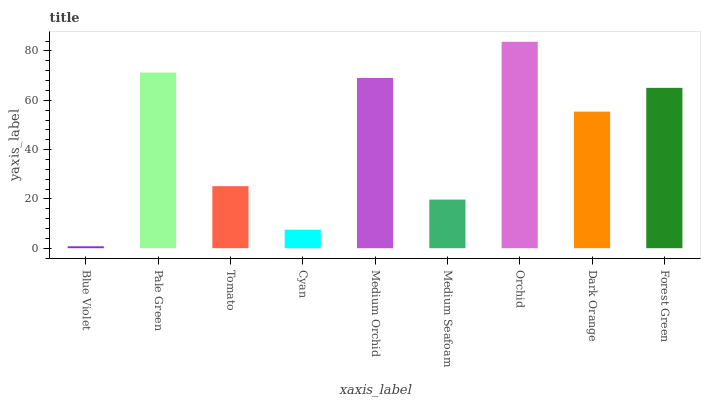Is Blue Violet the minimum?
Answer yes or no. Yes. Is Orchid the maximum?
Answer yes or no. Yes. Is Pale Green the minimum?
Answer yes or no. No. Is Pale Green the maximum?
Answer yes or no. No. Is Pale Green greater than Blue Violet?
Answer yes or no. Yes. Is Blue Violet less than Pale Green?
Answer yes or no. Yes. Is Blue Violet greater than Pale Green?
Answer yes or no. No. Is Pale Green less than Blue Violet?
Answer yes or no. No. Is Dark Orange the high median?
Answer yes or no. Yes. Is Dark Orange the low median?
Answer yes or no. Yes. Is Pale Green the high median?
Answer yes or no. No. Is Blue Violet the low median?
Answer yes or no. No. 